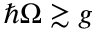<formula> <loc_0><loc_0><loc_500><loc_500>\hbar { \Omega } \gtrsim g</formula> 